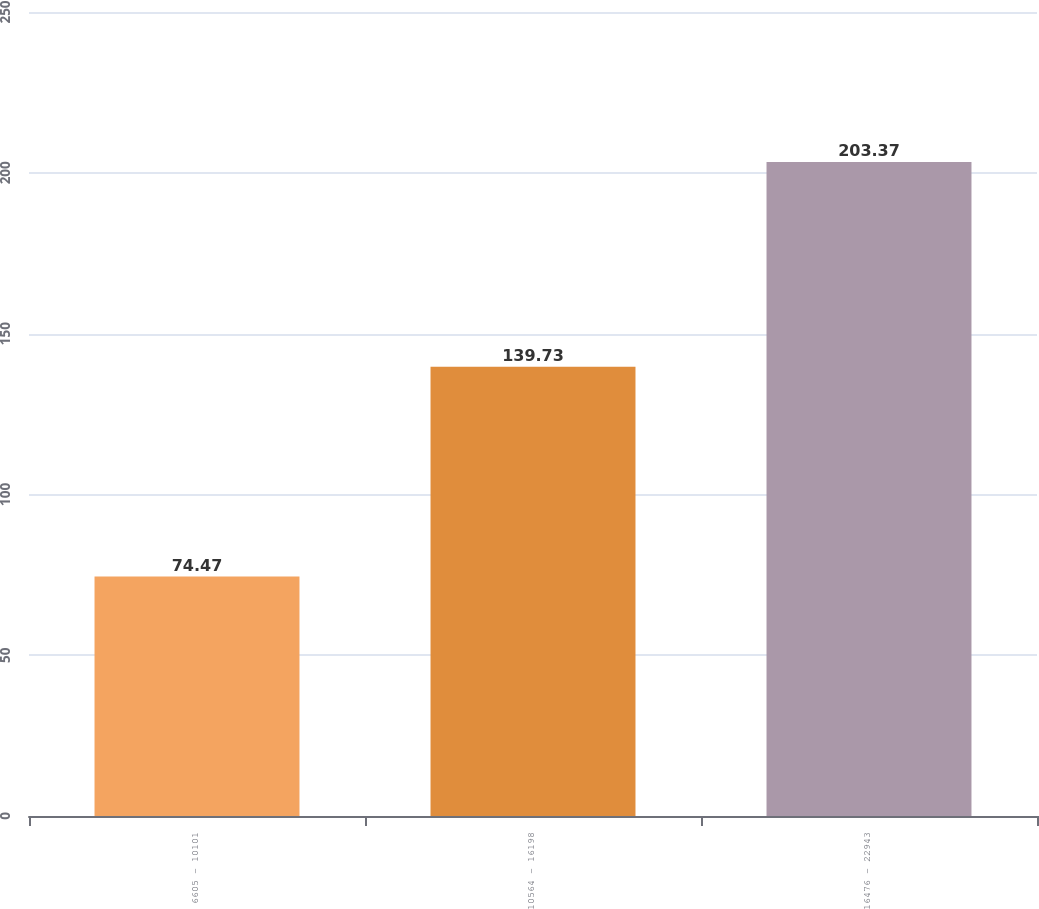<chart> <loc_0><loc_0><loc_500><loc_500><bar_chart><fcel>6605 - 10101<fcel>10564 - 16198<fcel>16476 - 22943<nl><fcel>74.47<fcel>139.73<fcel>203.37<nl></chart> 